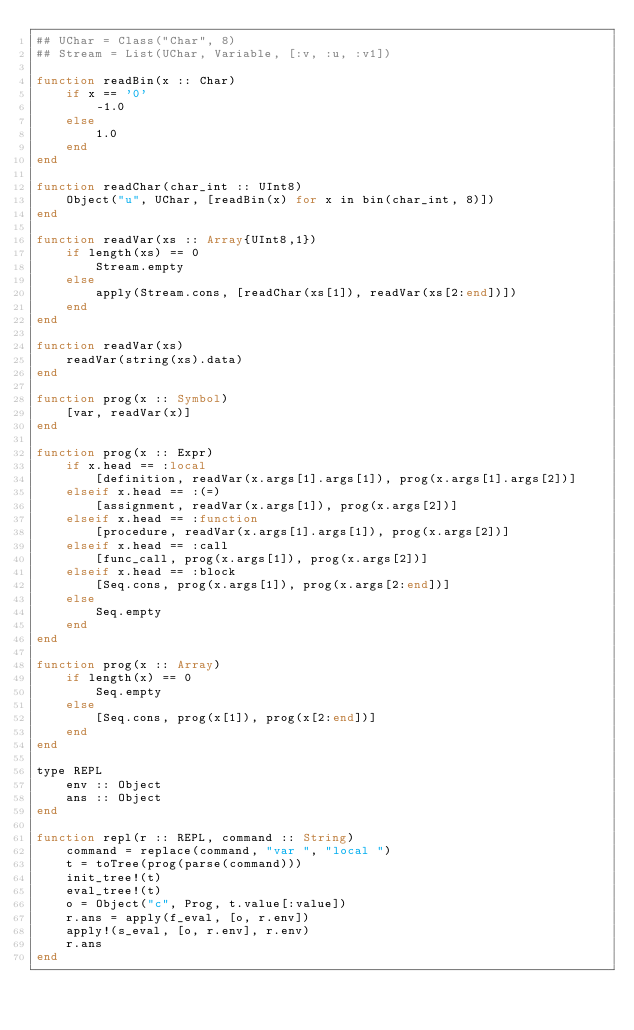Convert code to text. <code><loc_0><loc_0><loc_500><loc_500><_Julia_>## UChar = Class("Char", 8)
## Stream = List(UChar, Variable, [:v, :u, :v1])

function readBin(x :: Char)
    if x == '0'
        -1.0
    else
        1.0
    end
end
    
function readChar(char_int :: UInt8)
    Object("u", UChar, [readBin(x) for x in bin(char_int, 8)])
end

function readVar(xs :: Array{UInt8,1})
    if length(xs) == 0
        Stream.empty
    else
        apply(Stream.cons, [readChar(xs[1]), readVar(xs[2:end])])
    end
end

function readVar(xs)
    readVar(string(xs).data)
end

function prog(x :: Symbol)
    [var, readVar(x)]
end

function prog(x :: Expr)
    if x.head == :local
        [definition, readVar(x.args[1].args[1]), prog(x.args[1].args[2])]
    elseif x.head == :(=)
        [assignment, readVar(x.args[1]), prog(x.args[2])]
    elseif x.head == :function
        [procedure, readVar(x.args[1].args[1]), prog(x.args[2])]
    elseif x.head == :call
        [func_call, prog(x.args[1]), prog(x.args[2])]
    elseif x.head == :block
        [Seq.cons, prog(x.args[1]), prog(x.args[2:end])]
    else
        Seq.empty
    end
end

function prog(x :: Array)
    if length(x) == 0
        Seq.empty
    else
        [Seq.cons, prog(x[1]), prog(x[2:end])]
    end
end

type REPL
    env :: Object
    ans :: Object
end

function repl(r :: REPL, command :: String)
    command = replace(command, "var ", "local ")
    t = toTree(prog(parse(command)))
    init_tree!(t)
    eval_tree!(t)
    o = Object("c", Prog, t.value[:value])
    r.ans = apply(f_eval, [o, r.env])
    apply!(s_eval, [o, r.env], r.env)
    r.ans
end
</code> 